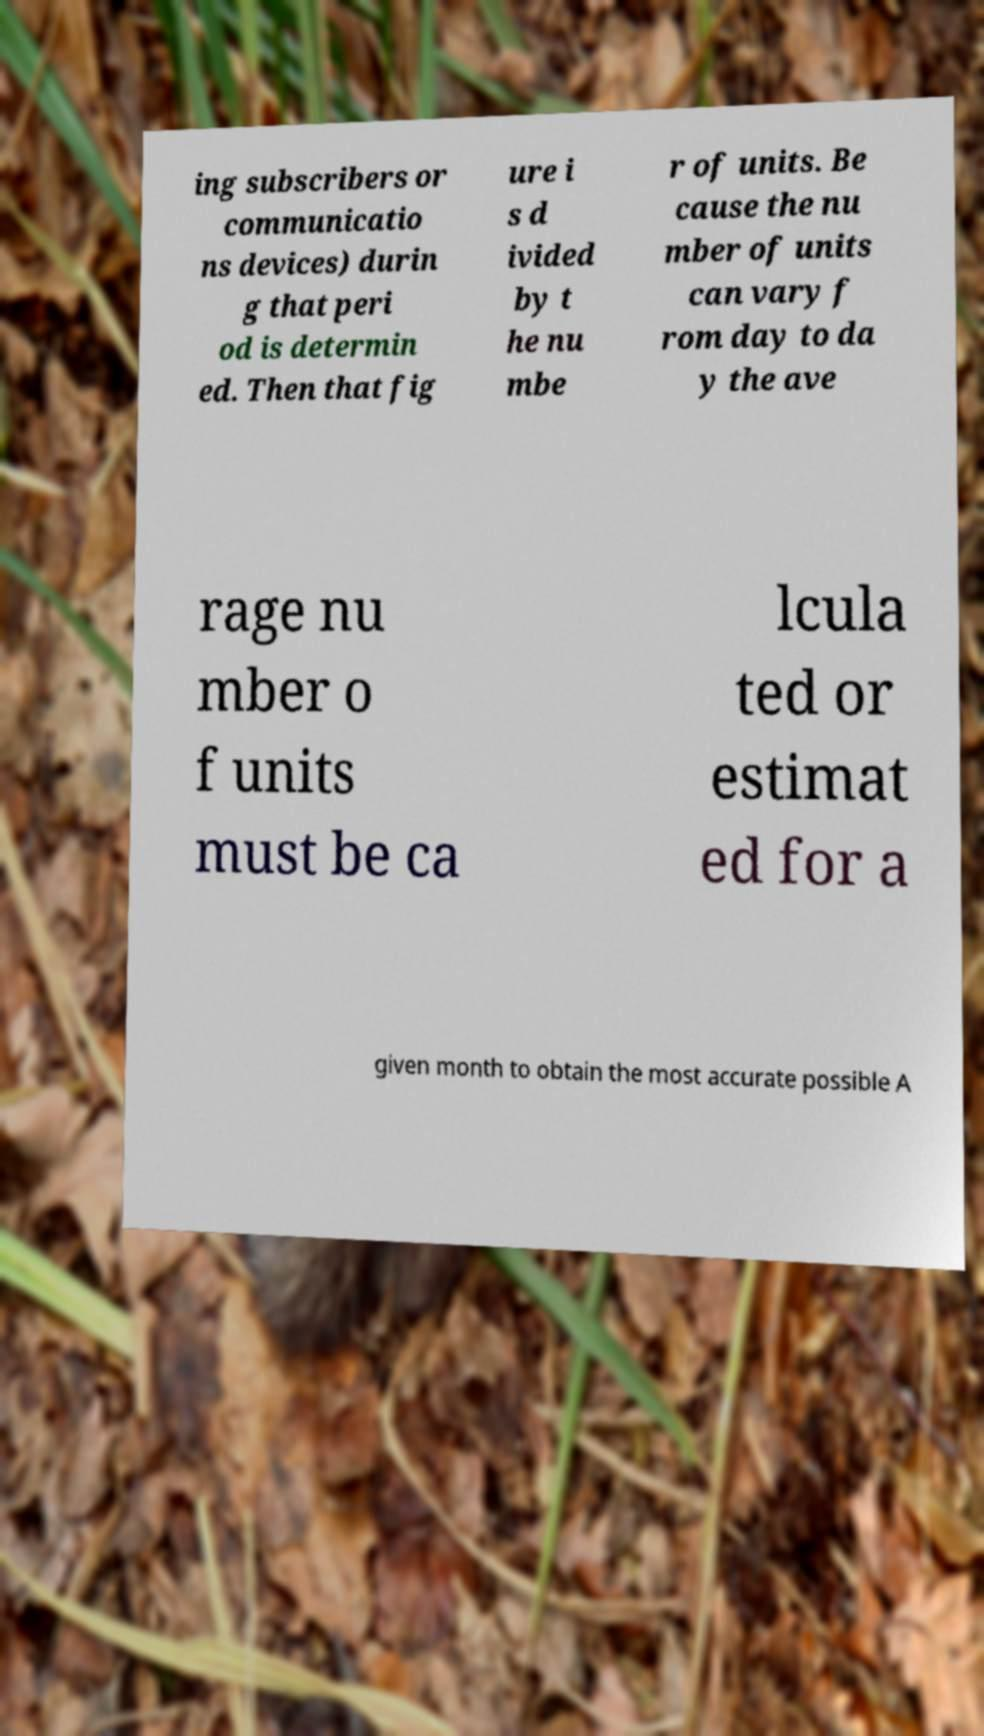Can you accurately transcribe the text from the provided image for me? ing subscribers or communicatio ns devices) durin g that peri od is determin ed. Then that fig ure i s d ivided by t he nu mbe r of units. Be cause the nu mber of units can vary f rom day to da y the ave rage nu mber o f units must be ca lcula ted or estimat ed for a given month to obtain the most accurate possible A 